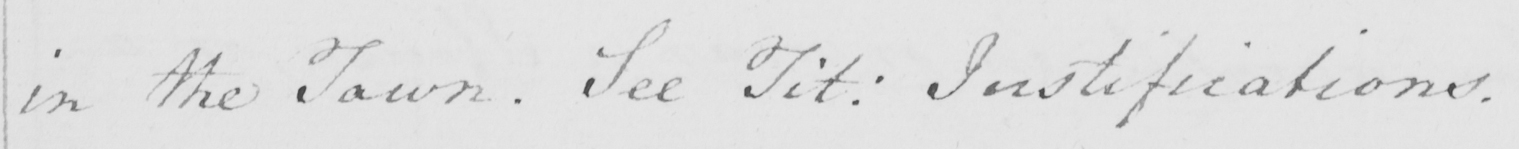Please provide the text content of this handwritten line. in the Town . See Tit :  Justifications . 